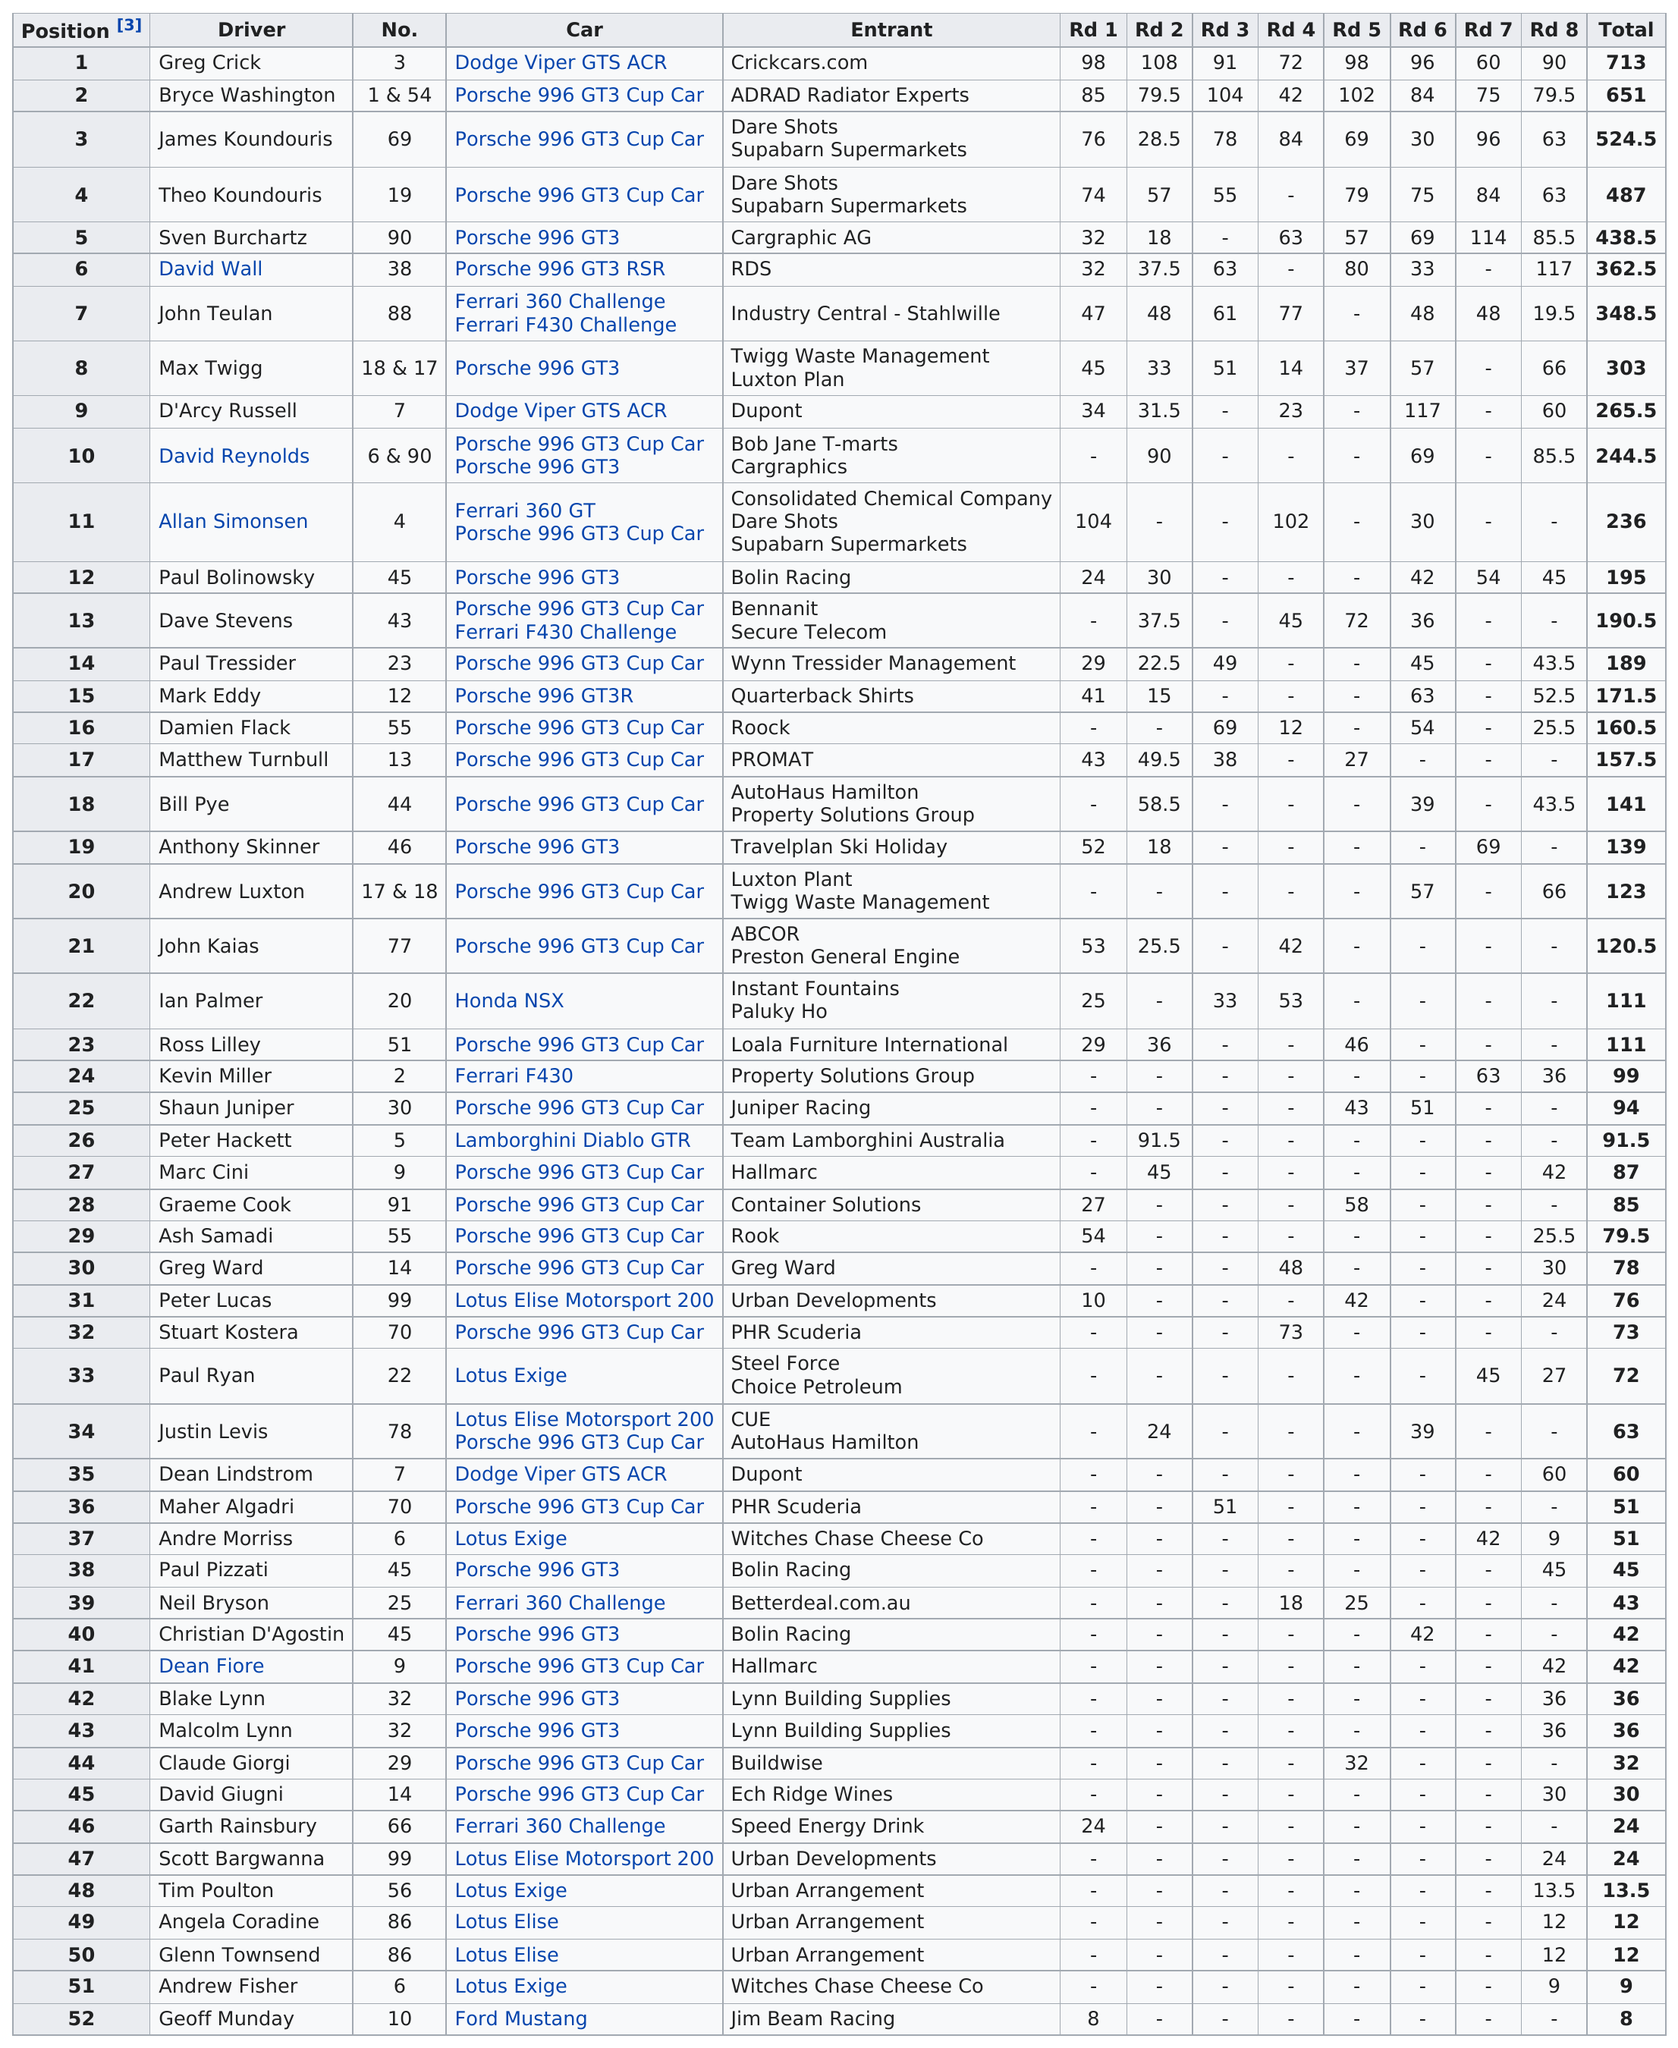Mention a couple of crucial points in this snapshot. The difference in total between position 1 and position 3 is 188.5. The person drove a Dodge Viper GTS ACR, a type of car. The Porsche 996 GT3 was driven by the greatest number of members. It is uncertain how many drivers appear in this table, as the information is not provided in the given text. Out of the total number of racers participating in at least 5 races, 11 racers scored. 